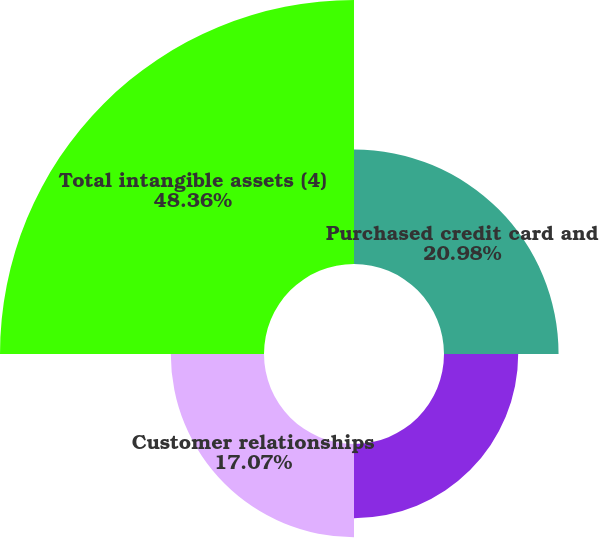<chart> <loc_0><loc_0><loc_500><loc_500><pie_chart><fcel>Purchased credit card and<fcel>Core deposit and other<fcel>Customer relationships<fcel>Total intangible assets (4)<nl><fcel>20.98%<fcel>13.59%<fcel>17.07%<fcel>48.35%<nl></chart> 